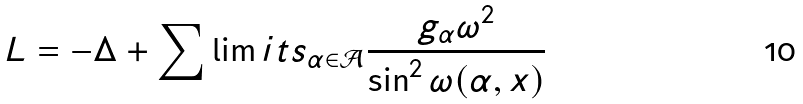<formula> <loc_0><loc_0><loc_500><loc_500>L = - \Delta + \sum \lim i t s _ { \alpha \in { \mathcal { A } } } \frac { g _ { \alpha } \omega ^ { 2 } } { \sin ^ { 2 } \omega ( \alpha , x ) }</formula> 